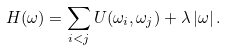Convert formula to latex. <formula><loc_0><loc_0><loc_500><loc_500>H ( \omega ) = \sum _ { i < j } U ( \omega _ { i } , \omega _ { j } ) + \lambda \left | \omega \right | .</formula> 